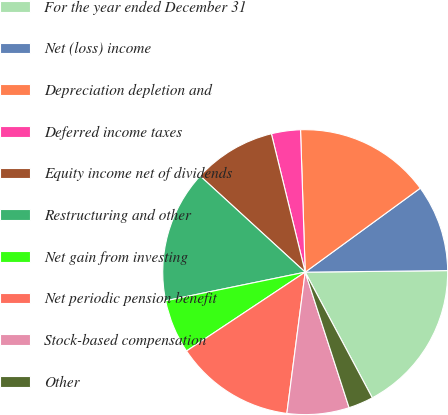<chart> <loc_0><loc_0><loc_500><loc_500><pie_chart><fcel>For the year ended December 31<fcel>Net (loss) income<fcel>Depreciation depletion and<fcel>Deferred income taxes<fcel>Equity income net of dividends<fcel>Restructuring and other<fcel>Net gain from investing<fcel>Net periodic pension benefit<fcel>Stock-based compensation<fcel>Other<nl><fcel>17.37%<fcel>9.86%<fcel>15.49%<fcel>3.29%<fcel>9.39%<fcel>15.02%<fcel>6.11%<fcel>13.61%<fcel>7.04%<fcel>2.82%<nl></chart> 